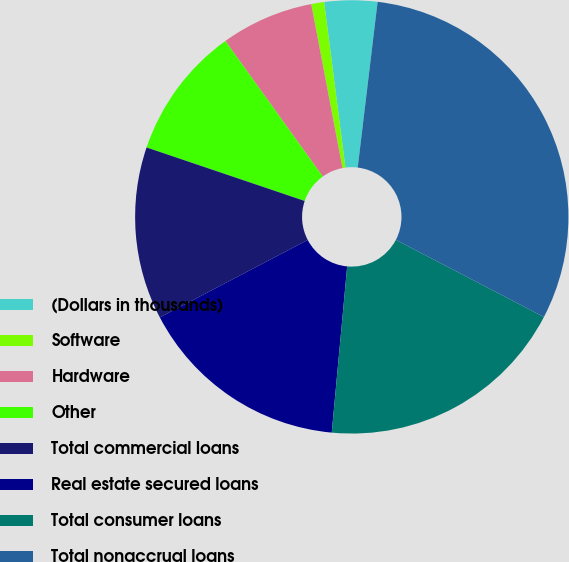<chart> <loc_0><loc_0><loc_500><loc_500><pie_chart><fcel>(Dollars in thousands)<fcel>Software<fcel>Hardware<fcel>Other<fcel>Total commercial loans<fcel>Real estate secured loans<fcel>Total consumer loans<fcel>Total nonaccrual loans<nl><fcel>3.94%<fcel>0.96%<fcel>6.92%<fcel>9.89%<fcel>12.87%<fcel>15.85%<fcel>18.83%<fcel>30.74%<nl></chart> 